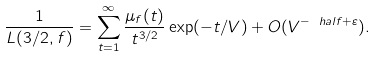<formula> <loc_0><loc_0><loc_500><loc_500>\frac { 1 } { L ( 3 / 2 , f ) } = \sum _ { t = 1 } ^ { \infty } \frac { \mu _ { f } ( t ) } { t ^ { 3 / 2 } } \exp ( - t / V ) + O ( V ^ { - \ h a l f + \varepsilon } ) .</formula> 